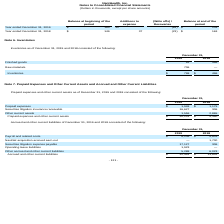From Nanthealth's financial document, What are the respective prepaid expenses in 2018 and 2019? The document shows two values: $1,179 and $1,948. From the document: "Prepaid expenses $ 1,948 $ 1,179 Prepaid expenses $ 1,948 $ 1,179..." Also, What are the respective securities litigation insurance receivable in 2018 and 2019? The document shows two values: 306 and 16,627. From the document: "Securities litigation insurance receivable 16,627 306 Securities litigation insurance receivable 16,627 306..." Also, What are the respective other current assets in 2018 and 2019?  The document shows two values: 2,865 and 1,556. From the document: "Other current assets 1,556 2,865 Other current assets 1,556 2,865..." Also, can you calculate: What is the percentage change in prepaid expenses between 2018 and 2019? To answer this question, I need to perform calculations using the financial data. The calculation is: (1,948 - 1,179)/1,179 , which equals 65.22 (percentage). This is based on the information: "Prepaid expenses $ 1,948 $ 1,179 Prepaid expenses $ 1,948 $ 1,179..." The key data points involved are: 1,179, 1,948. Also, can you calculate: What is the average prepaid expenses paid in 2018 and 2019? To answer this question, I need to perform calculations using the financial data. The calculation is: (1,948 + 1,179)/2 , which equals 1563.5. This is based on the information: "Prepaid expenses $ 1,948 $ 1,179 Prepaid expenses $ 1,948 $ 1,179..." The key data points involved are: 1,179, 1,948. Also, can you calculate: What is the total prepaid expenses made in 2018 and 2019? Based on the calculation: 1,948 + 1,179 , the result is 3127. This is based on the information: "Prepaid expenses $ 1,948 $ 1,179 Prepaid expenses $ 1,948 $ 1,179..." The key data points involved are: 1,179, 1,948. 